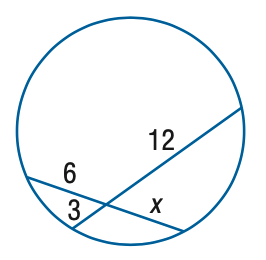Question: Find x.
Choices:
A. 3
B. 4
C. 5
D. 6
Answer with the letter. Answer: D 